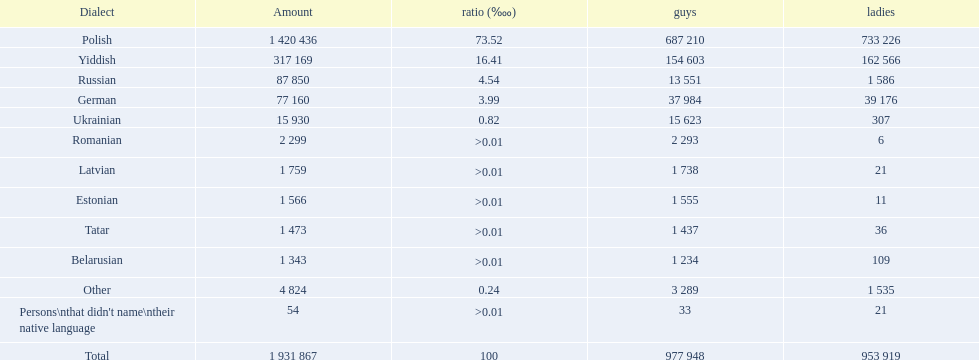How many languages are there? Polish, Yiddish, Russian, German, Ukrainian, Romanian, Latvian, Estonian, Tatar, Belarusian. Which language do more people speak? Polish. 